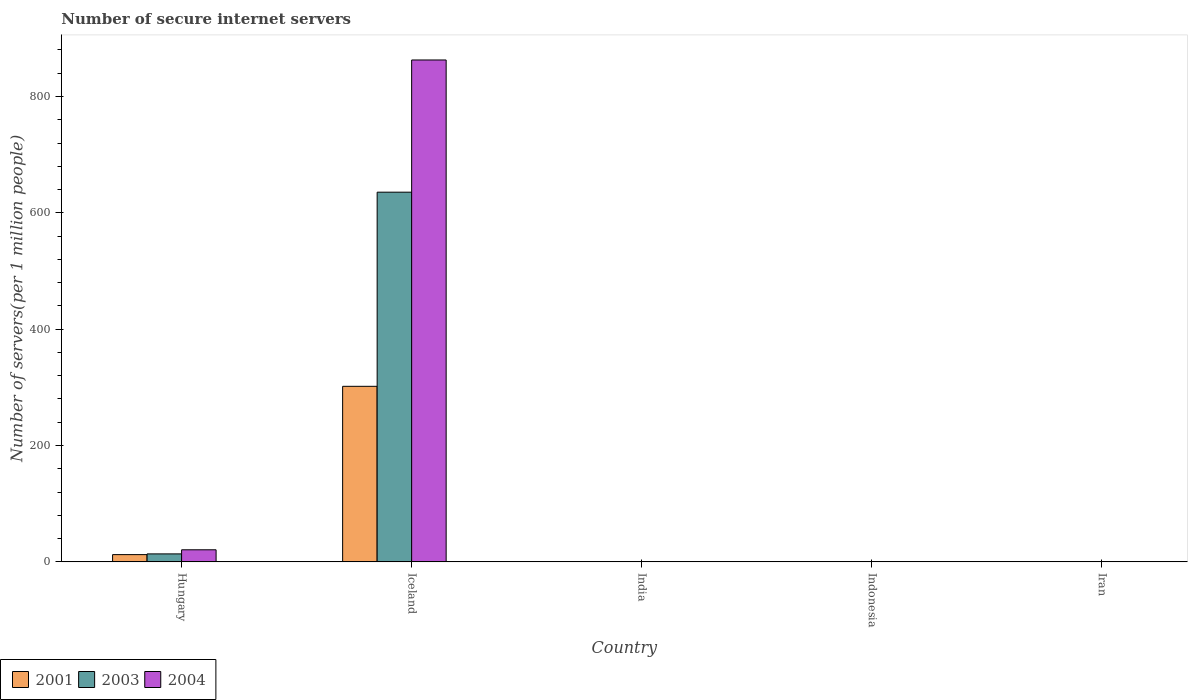How many groups of bars are there?
Make the answer very short. 5. Are the number of bars on each tick of the X-axis equal?
Offer a very short reply. Yes. How many bars are there on the 1st tick from the left?
Your answer should be compact. 3. How many bars are there on the 1st tick from the right?
Your answer should be compact. 3. What is the label of the 5th group of bars from the left?
Ensure brevity in your answer.  Iran. What is the number of secure internet servers in 2001 in Iceland?
Offer a terse response. 301.79. Across all countries, what is the maximum number of secure internet servers in 2003?
Provide a succinct answer. 635.53. Across all countries, what is the minimum number of secure internet servers in 2004?
Offer a terse response. 0.19. In which country was the number of secure internet servers in 2003 maximum?
Offer a very short reply. Iceland. In which country was the number of secure internet servers in 2003 minimum?
Give a very brief answer. Iran. What is the total number of secure internet servers in 2003 in the graph?
Keep it short and to the point. 649.8. What is the difference between the number of secure internet servers in 2004 in Hungary and that in Iceland?
Provide a succinct answer. -842.02. What is the difference between the number of secure internet servers in 2001 in Hungary and the number of secure internet servers in 2003 in Iran?
Provide a succinct answer. 12.45. What is the average number of secure internet servers in 2003 per country?
Make the answer very short. 129.96. What is the difference between the number of secure internet servers of/in 2003 and number of secure internet servers of/in 2004 in India?
Ensure brevity in your answer.  -0.16. In how many countries, is the number of secure internet servers in 2003 greater than 440?
Provide a short and direct response. 1. What is the ratio of the number of secure internet servers in 2004 in India to that in Iran?
Keep it short and to the point. 2.19. What is the difference between the highest and the second highest number of secure internet servers in 2004?
Keep it short and to the point. -20.37. What is the difference between the highest and the lowest number of secure internet servers in 2001?
Keep it short and to the point. 301.77. Is the sum of the number of secure internet servers in 2004 in Indonesia and Iran greater than the maximum number of secure internet servers in 2003 across all countries?
Ensure brevity in your answer.  No. What does the 1st bar from the left in Iceland represents?
Your answer should be compact. 2001. What does the 1st bar from the right in Indonesia represents?
Provide a succinct answer. 2004. How many countries are there in the graph?
Ensure brevity in your answer.  5. What is the difference between two consecutive major ticks on the Y-axis?
Ensure brevity in your answer.  200. Are the values on the major ticks of Y-axis written in scientific E-notation?
Make the answer very short. No. Does the graph contain any zero values?
Your response must be concise. No. Does the graph contain grids?
Provide a short and direct response. No. Where does the legend appear in the graph?
Offer a very short reply. Bottom left. How many legend labels are there?
Your answer should be compact. 3. What is the title of the graph?
Give a very brief answer. Number of secure internet servers. What is the label or title of the Y-axis?
Keep it short and to the point. Number of servers(per 1 million people). What is the Number of servers(per 1 million people) of 2001 in Hungary?
Offer a very short reply. 12.47. What is the Number of servers(per 1 million people) in 2003 in Hungary?
Offer a very short reply. 13.72. What is the Number of servers(per 1 million people) of 2004 in Hungary?
Give a very brief answer. 20.78. What is the Number of servers(per 1 million people) in 2001 in Iceland?
Your response must be concise. 301.79. What is the Number of servers(per 1 million people) of 2003 in Iceland?
Your answer should be very brief. 635.53. What is the Number of servers(per 1 million people) in 2004 in Iceland?
Your response must be concise. 862.8. What is the Number of servers(per 1 million people) in 2001 in India?
Keep it short and to the point. 0.11. What is the Number of servers(per 1 million people) in 2003 in India?
Make the answer very short. 0.25. What is the Number of servers(per 1 million people) in 2004 in India?
Offer a very short reply. 0.41. What is the Number of servers(per 1 million people) of 2001 in Indonesia?
Your response must be concise. 0.28. What is the Number of servers(per 1 million people) in 2003 in Indonesia?
Offer a very short reply. 0.27. What is the Number of servers(per 1 million people) of 2004 in Indonesia?
Your response must be concise. 0.38. What is the Number of servers(per 1 million people) of 2001 in Iran?
Provide a short and direct response. 0.01. What is the Number of servers(per 1 million people) of 2003 in Iran?
Offer a terse response. 0.01. What is the Number of servers(per 1 million people) in 2004 in Iran?
Provide a succinct answer. 0.19. Across all countries, what is the maximum Number of servers(per 1 million people) in 2001?
Your answer should be very brief. 301.79. Across all countries, what is the maximum Number of servers(per 1 million people) of 2003?
Keep it short and to the point. 635.53. Across all countries, what is the maximum Number of servers(per 1 million people) of 2004?
Keep it short and to the point. 862.8. Across all countries, what is the minimum Number of servers(per 1 million people) of 2001?
Give a very brief answer. 0.01. Across all countries, what is the minimum Number of servers(per 1 million people) of 2003?
Offer a very short reply. 0.01. Across all countries, what is the minimum Number of servers(per 1 million people) of 2004?
Give a very brief answer. 0.19. What is the total Number of servers(per 1 million people) of 2001 in the graph?
Provide a succinct answer. 314.66. What is the total Number of servers(per 1 million people) of 2003 in the graph?
Keep it short and to the point. 649.8. What is the total Number of servers(per 1 million people) of 2004 in the graph?
Provide a succinct answer. 884.55. What is the difference between the Number of servers(per 1 million people) of 2001 in Hungary and that in Iceland?
Ensure brevity in your answer.  -289.32. What is the difference between the Number of servers(per 1 million people) in 2003 in Hungary and that in Iceland?
Provide a succinct answer. -621.81. What is the difference between the Number of servers(per 1 million people) in 2004 in Hungary and that in Iceland?
Offer a very short reply. -842.02. What is the difference between the Number of servers(per 1 million people) in 2001 in Hungary and that in India?
Give a very brief answer. 12.35. What is the difference between the Number of servers(per 1 million people) in 2003 in Hungary and that in India?
Your response must be concise. 13.47. What is the difference between the Number of servers(per 1 million people) of 2004 in Hungary and that in India?
Ensure brevity in your answer.  20.37. What is the difference between the Number of servers(per 1 million people) in 2001 in Hungary and that in Indonesia?
Keep it short and to the point. 12.19. What is the difference between the Number of servers(per 1 million people) of 2003 in Hungary and that in Indonesia?
Provide a short and direct response. 13.45. What is the difference between the Number of servers(per 1 million people) in 2004 in Hungary and that in Indonesia?
Provide a short and direct response. 20.4. What is the difference between the Number of servers(per 1 million people) of 2001 in Hungary and that in Iran?
Provide a succinct answer. 12.45. What is the difference between the Number of servers(per 1 million people) of 2003 in Hungary and that in Iran?
Provide a succinct answer. 13.71. What is the difference between the Number of servers(per 1 million people) in 2004 in Hungary and that in Iran?
Make the answer very short. 20.59. What is the difference between the Number of servers(per 1 million people) of 2001 in Iceland and that in India?
Provide a succinct answer. 301.67. What is the difference between the Number of servers(per 1 million people) in 2003 in Iceland and that in India?
Your answer should be compact. 635.28. What is the difference between the Number of servers(per 1 million people) in 2004 in Iceland and that in India?
Your answer should be compact. 862.38. What is the difference between the Number of servers(per 1 million people) in 2001 in Iceland and that in Indonesia?
Your answer should be compact. 301.51. What is the difference between the Number of servers(per 1 million people) in 2003 in Iceland and that in Indonesia?
Offer a terse response. 635.26. What is the difference between the Number of servers(per 1 million people) in 2004 in Iceland and that in Indonesia?
Offer a terse response. 862.41. What is the difference between the Number of servers(per 1 million people) of 2001 in Iceland and that in Iran?
Offer a terse response. 301.77. What is the difference between the Number of servers(per 1 million people) in 2003 in Iceland and that in Iran?
Provide a short and direct response. 635.52. What is the difference between the Number of servers(per 1 million people) in 2004 in Iceland and that in Iran?
Give a very brief answer. 862.61. What is the difference between the Number of servers(per 1 million people) of 2001 in India and that in Indonesia?
Provide a short and direct response. -0.17. What is the difference between the Number of servers(per 1 million people) in 2003 in India and that in Indonesia?
Your response must be concise. -0.02. What is the difference between the Number of servers(per 1 million people) of 2004 in India and that in Indonesia?
Give a very brief answer. 0.03. What is the difference between the Number of servers(per 1 million people) in 2001 in India and that in Iran?
Give a very brief answer. 0.1. What is the difference between the Number of servers(per 1 million people) in 2003 in India and that in Iran?
Offer a terse response. 0.24. What is the difference between the Number of servers(per 1 million people) of 2004 in India and that in Iran?
Your answer should be very brief. 0.22. What is the difference between the Number of servers(per 1 million people) of 2001 in Indonesia and that in Iran?
Offer a very short reply. 0.26. What is the difference between the Number of servers(per 1 million people) in 2003 in Indonesia and that in Iran?
Your response must be concise. 0.26. What is the difference between the Number of servers(per 1 million people) in 2004 in Indonesia and that in Iran?
Ensure brevity in your answer.  0.19. What is the difference between the Number of servers(per 1 million people) of 2001 in Hungary and the Number of servers(per 1 million people) of 2003 in Iceland?
Make the answer very short. -623.07. What is the difference between the Number of servers(per 1 million people) in 2001 in Hungary and the Number of servers(per 1 million people) in 2004 in Iceland?
Give a very brief answer. -850.33. What is the difference between the Number of servers(per 1 million people) in 2003 in Hungary and the Number of servers(per 1 million people) in 2004 in Iceland?
Provide a succinct answer. -849.07. What is the difference between the Number of servers(per 1 million people) of 2001 in Hungary and the Number of servers(per 1 million people) of 2003 in India?
Your answer should be very brief. 12.21. What is the difference between the Number of servers(per 1 million people) in 2001 in Hungary and the Number of servers(per 1 million people) in 2004 in India?
Offer a terse response. 12.06. What is the difference between the Number of servers(per 1 million people) in 2003 in Hungary and the Number of servers(per 1 million people) in 2004 in India?
Keep it short and to the point. 13.31. What is the difference between the Number of servers(per 1 million people) in 2001 in Hungary and the Number of servers(per 1 million people) in 2003 in Indonesia?
Give a very brief answer. 12.19. What is the difference between the Number of servers(per 1 million people) of 2001 in Hungary and the Number of servers(per 1 million people) of 2004 in Indonesia?
Provide a succinct answer. 12.09. What is the difference between the Number of servers(per 1 million people) of 2003 in Hungary and the Number of servers(per 1 million people) of 2004 in Indonesia?
Give a very brief answer. 13.34. What is the difference between the Number of servers(per 1 million people) of 2001 in Hungary and the Number of servers(per 1 million people) of 2003 in Iran?
Your response must be concise. 12.45. What is the difference between the Number of servers(per 1 million people) in 2001 in Hungary and the Number of servers(per 1 million people) in 2004 in Iran?
Make the answer very short. 12.28. What is the difference between the Number of servers(per 1 million people) of 2003 in Hungary and the Number of servers(per 1 million people) of 2004 in Iran?
Your response must be concise. 13.53. What is the difference between the Number of servers(per 1 million people) in 2001 in Iceland and the Number of servers(per 1 million people) in 2003 in India?
Make the answer very short. 301.53. What is the difference between the Number of servers(per 1 million people) in 2001 in Iceland and the Number of servers(per 1 million people) in 2004 in India?
Ensure brevity in your answer.  301.38. What is the difference between the Number of servers(per 1 million people) of 2003 in Iceland and the Number of servers(per 1 million people) of 2004 in India?
Your answer should be compact. 635.12. What is the difference between the Number of servers(per 1 million people) of 2001 in Iceland and the Number of servers(per 1 million people) of 2003 in Indonesia?
Offer a very short reply. 301.52. What is the difference between the Number of servers(per 1 million people) in 2001 in Iceland and the Number of servers(per 1 million people) in 2004 in Indonesia?
Your answer should be very brief. 301.41. What is the difference between the Number of servers(per 1 million people) in 2003 in Iceland and the Number of servers(per 1 million people) in 2004 in Indonesia?
Give a very brief answer. 635.15. What is the difference between the Number of servers(per 1 million people) of 2001 in Iceland and the Number of servers(per 1 million people) of 2003 in Iran?
Your answer should be very brief. 301.77. What is the difference between the Number of servers(per 1 million people) in 2001 in Iceland and the Number of servers(per 1 million people) in 2004 in Iran?
Your answer should be compact. 301.6. What is the difference between the Number of servers(per 1 million people) of 2003 in Iceland and the Number of servers(per 1 million people) of 2004 in Iran?
Make the answer very short. 635.35. What is the difference between the Number of servers(per 1 million people) of 2001 in India and the Number of servers(per 1 million people) of 2003 in Indonesia?
Ensure brevity in your answer.  -0.16. What is the difference between the Number of servers(per 1 million people) in 2001 in India and the Number of servers(per 1 million people) in 2004 in Indonesia?
Offer a terse response. -0.27. What is the difference between the Number of servers(per 1 million people) in 2003 in India and the Number of servers(per 1 million people) in 2004 in Indonesia?
Keep it short and to the point. -0.13. What is the difference between the Number of servers(per 1 million people) of 2001 in India and the Number of servers(per 1 million people) of 2003 in Iran?
Your answer should be very brief. 0.1. What is the difference between the Number of servers(per 1 million people) in 2001 in India and the Number of servers(per 1 million people) in 2004 in Iran?
Provide a succinct answer. -0.07. What is the difference between the Number of servers(per 1 million people) of 2003 in India and the Number of servers(per 1 million people) of 2004 in Iran?
Offer a very short reply. 0.07. What is the difference between the Number of servers(per 1 million people) of 2001 in Indonesia and the Number of servers(per 1 million people) of 2003 in Iran?
Provide a short and direct response. 0.27. What is the difference between the Number of servers(per 1 million people) of 2001 in Indonesia and the Number of servers(per 1 million people) of 2004 in Iran?
Give a very brief answer. 0.09. What is the difference between the Number of servers(per 1 million people) in 2003 in Indonesia and the Number of servers(per 1 million people) in 2004 in Iran?
Provide a succinct answer. 0.08. What is the average Number of servers(per 1 million people) in 2001 per country?
Provide a short and direct response. 62.93. What is the average Number of servers(per 1 million people) of 2003 per country?
Offer a very short reply. 129.96. What is the average Number of servers(per 1 million people) of 2004 per country?
Your response must be concise. 176.91. What is the difference between the Number of servers(per 1 million people) in 2001 and Number of servers(per 1 million people) in 2003 in Hungary?
Your answer should be very brief. -1.26. What is the difference between the Number of servers(per 1 million people) of 2001 and Number of servers(per 1 million people) of 2004 in Hungary?
Offer a terse response. -8.31. What is the difference between the Number of servers(per 1 million people) in 2003 and Number of servers(per 1 million people) in 2004 in Hungary?
Offer a very short reply. -7.06. What is the difference between the Number of servers(per 1 million people) in 2001 and Number of servers(per 1 million people) in 2003 in Iceland?
Your answer should be compact. -333.74. What is the difference between the Number of servers(per 1 million people) in 2001 and Number of servers(per 1 million people) in 2004 in Iceland?
Your response must be concise. -561.01. What is the difference between the Number of servers(per 1 million people) of 2003 and Number of servers(per 1 million people) of 2004 in Iceland?
Your answer should be very brief. -227.26. What is the difference between the Number of servers(per 1 million people) in 2001 and Number of servers(per 1 million people) in 2003 in India?
Provide a short and direct response. -0.14. What is the difference between the Number of servers(per 1 million people) in 2001 and Number of servers(per 1 million people) in 2004 in India?
Offer a very short reply. -0.3. What is the difference between the Number of servers(per 1 million people) in 2003 and Number of servers(per 1 million people) in 2004 in India?
Make the answer very short. -0.16. What is the difference between the Number of servers(per 1 million people) of 2001 and Number of servers(per 1 million people) of 2003 in Indonesia?
Provide a short and direct response. 0.01. What is the difference between the Number of servers(per 1 million people) of 2001 and Number of servers(per 1 million people) of 2004 in Indonesia?
Your answer should be very brief. -0.1. What is the difference between the Number of servers(per 1 million people) in 2003 and Number of servers(per 1 million people) in 2004 in Indonesia?
Your response must be concise. -0.11. What is the difference between the Number of servers(per 1 million people) of 2001 and Number of servers(per 1 million people) of 2003 in Iran?
Ensure brevity in your answer.  0. What is the difference between the Number of servers(per 1 million people) of 2001 and Number of servers(per 1 million people) of 2004 in Iran?
Your response must be concise. -0.17. What is the difference between the Number of servers(per 1 million people) of 2003 and Number of servers(per 1 million people) of 2004 in Iran?
Offer a terse response. -0.17. What is the ratio of the Number of servers(per 1 million people) in 2001 in Hungary to that in Iceland?
Offer a terse response. 0.04. What is the ratio of the Number of servers(per 1 million people) of 2003 in Hungary to that in Iceland?
Keep it short and to the point. 0.02. What is the ratio of the Number of servers(per 1 million people) in 2004 in Hungary to that in Iceland?
Make the answer very short. 0.02. What is the ratio of the Number of servers(per 1 million people) of 2001 in Hungary to that in India?
Offer a very short reply. 109.53. What is the ratio of the Number of servers(per 1 million people) of 2003 in Hungary to that in India?
Make the answer very short. 54.13. What is the ratio of the Number of servers(per 1 million people) in 2004 in Hungary to that in India?
Provide a short and direct response. 50.66. What is the ratio of the Number of servers(per 1 million people) in 2001 in Hungary to that in Indonesia?
Provide a succinct answer. 44.56. What is the ratio of the Number of servers(per 1 million people) of 2003 in Hungary to that in Indonesia?
Provide a short and direct response. 50.39. What is the ratio of the Number of servers(per 1 million people) in 2004 in Hungary to that in Indonesia?
Make the answer very short. 54.58. What is the ratio of the Number of servers(per 1 million people) in 2001 in Hungary to that in Iran?
Offer a terse response. 832.9. What is the ratio of the Number of servers(per 1 million people) of 2003 in Hungary to that in Iran?
Your response must be concise. 940.28. What is the ratio of the Number of servers(per 1 million people) in 2004 in Hungary to that in Iran?
Provide a succinct answer. 110.79. What is the ratio of the Number of servers(per 1 million people) of 2001 in Iceland to that in India?
Keep it short and to the point. 2651.5. What is the ratio of the Number of servers(per 1 million people) of 2003 in Iceland to that in India?
Make the answer very short. 2506.78. What is the ratio of the Number of servers(per 1 million people) in 2004 in Iceland to that in India?
Offer a terse response. 2103.61. What is the ratio of the Number of servers(per 1 million people) of 2001 in Iceland to that in Indonesia?
Offer a terse response. 1078.63. What is the ratio of the Number of servers(per 1 million people) of 2003 in Iceland to that in Indonesia?
Your answer should be very brief. 2333.55. What is the ratio of the Number of servers(per 1 million people) of 2004 in Iceland to that in Indonesia?
Ensure brevity in your answer.  2266.29. What is the ratio of the Number of servers(per 1 million people) of 2001 in Iceland to that in Iran?
Give a very brief answer. 2.02e+04. What is the ratio of the Number of servers(per 1 million people) in 2003 in Iceland to that in Iran?
Your answer should be very brief. 4.35e+04. What is the ratio of the Number of servers(per 1 million people) in 2004 in Iceland to that in Iran?
Make the answer very short. 4600.82. What is the ratio of the Number of servers(per 1 million people) in 2001 in India to that in Indonesia?
Make the answer very short. 0.41. What is the ratio of the Number of servers(per 1 million people) of 2003 in India to that in Indonesia?
Provide a succinct answer. 0.93. What is the ratio of the Number of servers(per 1 million people) in 2004 in India to that in Indonesia?
Offer a terse response. 1.08. What is the ratio of the Number of servers(per 1 million people) of 2001 in India to that in Iran?
Give a very brief answer. 7.6. What is the ratio of the Number of servers(per 1 million people) of 2003 in India to that in Iran?
Ensure brevity in your answer.  17.37. What is the ratio of the Number of servers(per 1 million people) of 2004 in India to that in Iran?
Your answer should be very brief. 2.19. What is the ratio of the Number of servers(per 1 million people) in 2001 in Indonesia to that in Iran?
Give a very brief answer. 18.69. What is the ratio of the Number of servers(per 1 million people) of 2003 in Indonesia to that in Iran?
Provide a short and direct response. 18.66. What is the ratio of the Number of servers(per 1 million people) in 2004 in Indonesia to that in Iran?
Offer a terse response. 2.03. What is the difference between the highest and the second highest Number of servers(per 1 million people) in 2001?
Keep it short and to the point. 289.32. What is the difference between the highest and the second highest Number of servers(per 1 million people) in 2003?
Offer a very short reply. 621.81. What is the difference between the highest and the second highest Number of servers(per 1 million people) in 2004?
Your response must be concise. 842.02. What is the difference between the highest and the lowest Number of servers(per 1 million people) in 2001?
Ensure brevity in your answer.  301.77. What is the difference between the highest and the lowest Number of servers(per 1 million people) of 2003?
Provide a succinct answer. 635.52. What is the difference between the highest and the lowest Number of servers(per 1 million people) in 2004?
Provide a short and direct response. 862.61. 